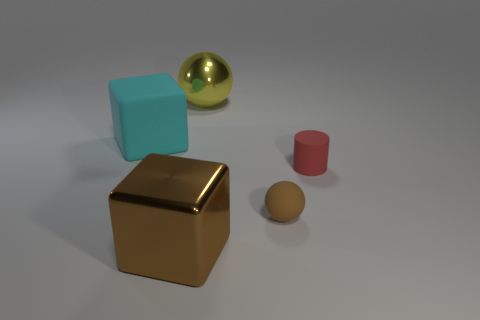Add 4 yellow cylinders. How many objects exist? 9 Subtract all cylinders. How many objects are left? 4 Subtract all small purple rubber cubes. Subtract all big cyan objects. How many objects are left? 4 Add 1 large cyan matte objects. How many large cyan matte objects are left? 2 Add 3 brown spheres. How many brown spheres exist? 4 Subtract 0 blue spheres. How many objects are left? 5 